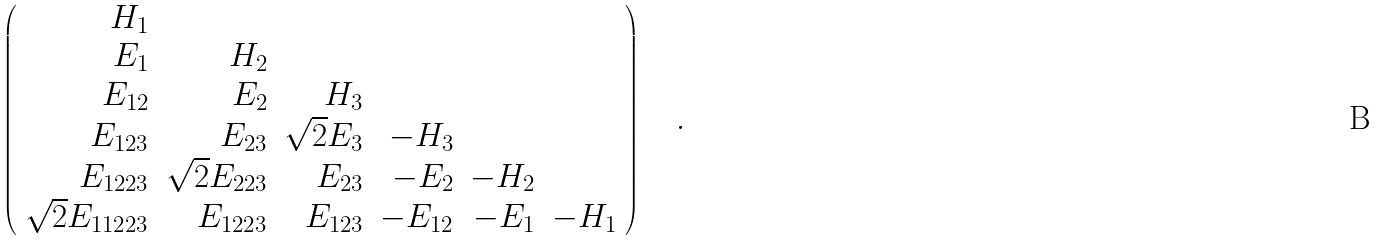<formula> <loc_0><loc_0><loc_500><loc_500>\left ( \begin{array} { r r r r r r } H _ { 1 } & & & & & \\ E _ { 1 } & H _ { 2 } & & & & \\ E _ { 1 2 } & E _ { 2 } & H _ { 3 } & & & \\ E _ { 1 2 3 } & E _ { 2 3 } & \sqrt { 2 } E _ { 3 } & - H _ { 3 } & & \\ E _ { 1 2 2 3 } & \sqrt { 2 } E _ { 2 2 3 } & E _ { 2 3 } & - E _ { 2 } & - H _ { 2 } & \\ \sqrt { 2 } E _ { 1 1 2 2 3 } & E _ { 1 2 2 3 } & E _ { 1 2 3 } & - E _ { 1 2 } & - E _ { 1 } & - H _ { 1 } \end{array} \right ) \quad .</formula> 